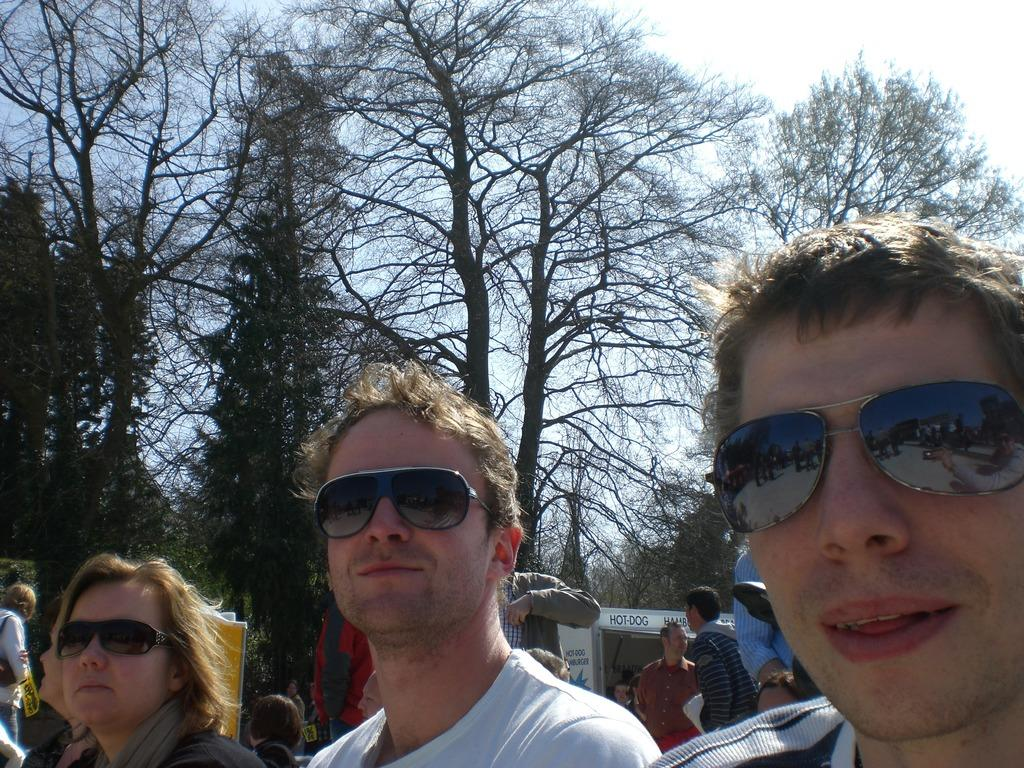Provide a one-sentence caption for the provided image. People are sitting in front of a hamburger and hotdog stand. 